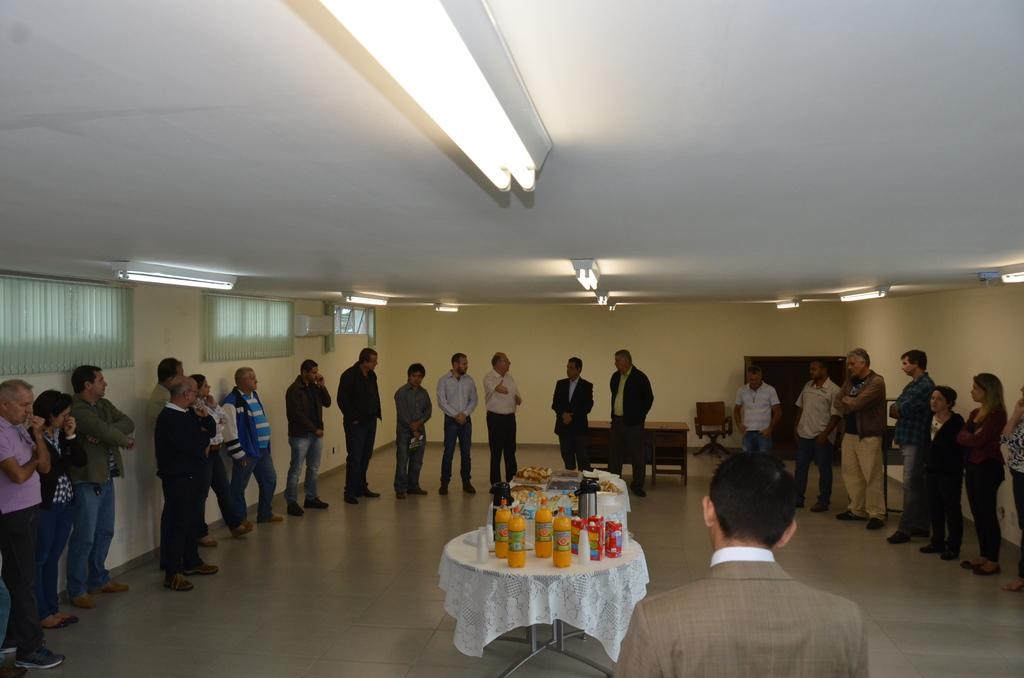How many people are in the room in the image? There is a group of people in the room, but the exact number cannot be determined from the image. What is on the table in the room? There is a bottle and food on the table in the room. What type of furniture is in the room? There is a table and a chair in the room. What can be seen in the background of the room? There is a wall in the background of the room. Can you tell me how many yaks are in the room? There are no yaks present in the room; the image only shows a group of people, a table, a chair, a bottle, food, and a wall in the background. 